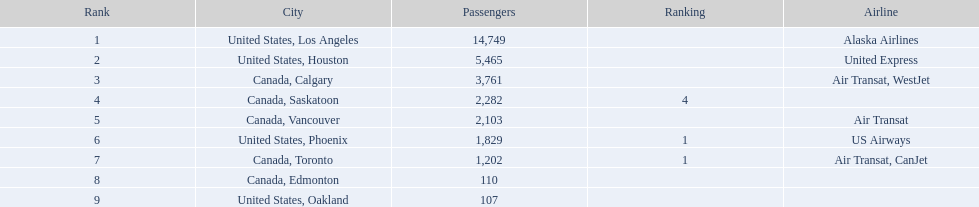What are the airport's destinations? United States, Los Angeles, United States, Houston, Canada, Calgary, Canada, Saskatoon, Canada, Vancouver, United States, Phoenix, Canada, Toronto, Canada, Edmonton, United States, Oakland. How many passengers are traveling to phoenix? 1,829. In which cities did the number of passengers not exceed 2,000? United States, Phoenix, Canada, Toronto, Canada, Edmonton, United States, Oakland. Of these cities, which had a passenger count of less than 1,000? Canada, Edmonton, United States, Oakland. Among the cities mentioned earlier, which specific city had a total of 107 passengers? United States, Oakland. 